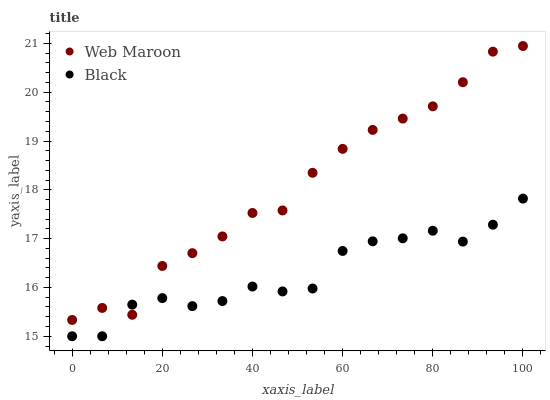Does Black have the minimum area under the curve?
Answer yes or no. Yes. Does Web Maroon have the maximum area under the curve?
Answer yes or no. Yes. Does Web Maroon have the minimum area under the curve?
Answer yes or no. No. Is Web Maroon the smoothest?
Answer yes or no. Yes. Is Black the roughest?
Answer yes or no. Yes. Is Web Maroon the roughest?
Answer yes or no. No. Does Black have the lowest value?
Answer yes or no. Yes. Does Web Maroon have the lowest value?
Answer yes or no. No. Does Web Maroon have the highest value?
Answer yes or no. Yes. Does Web Maroon intersect Black?
Answer yes or no. Yes. Is Web Maroon less than Black?
Answer yes or no. No. Is Web Maroon greater than Black?
Answer yes or no. No. 